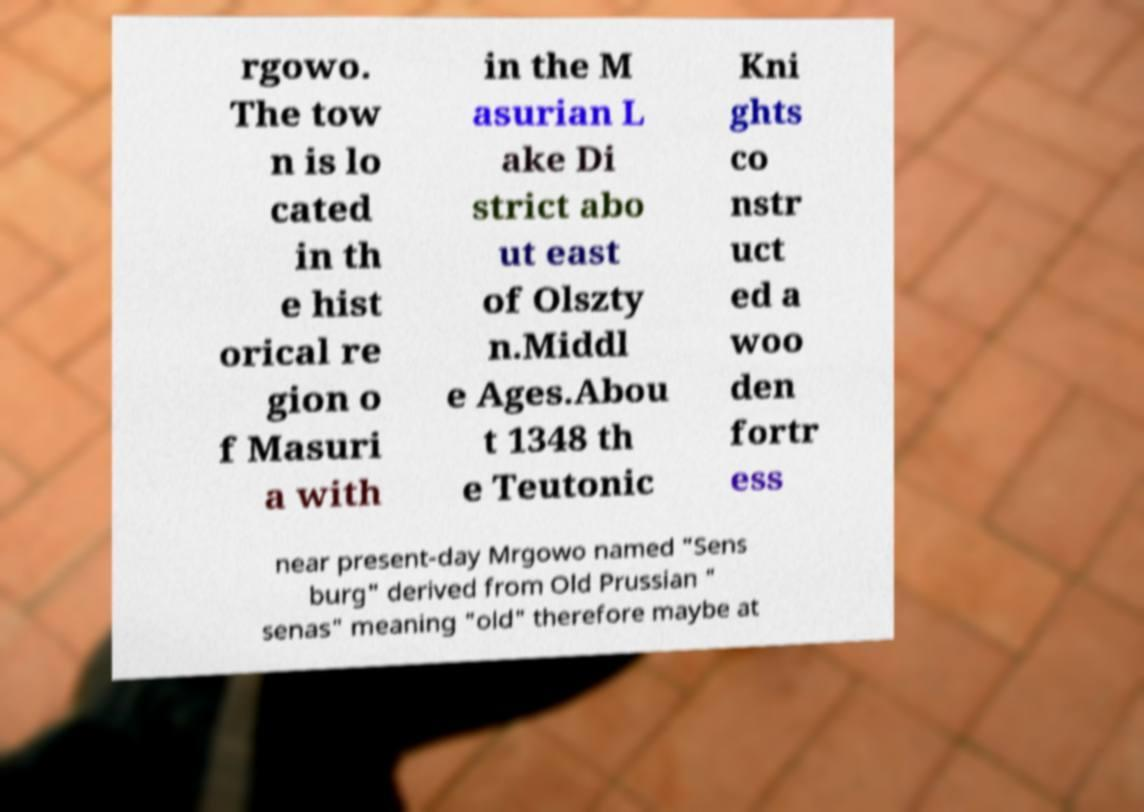What messages or text are displayed in this image? I need them in a readable, typed format. rgowo. The tow n is lo cated in th e hist orical re gion o f Masuri a with in the M asurian L ake Di strict abo ut east of Olszty n.Middl e Ages.Abou t 1348 th e Teutonic Kni ghts co nstr uct ed a woo den fortr ess near present-day Mrgowo named "Sens burg" derived from Old Prussian " senas" meaning "old" therefore maybe at 